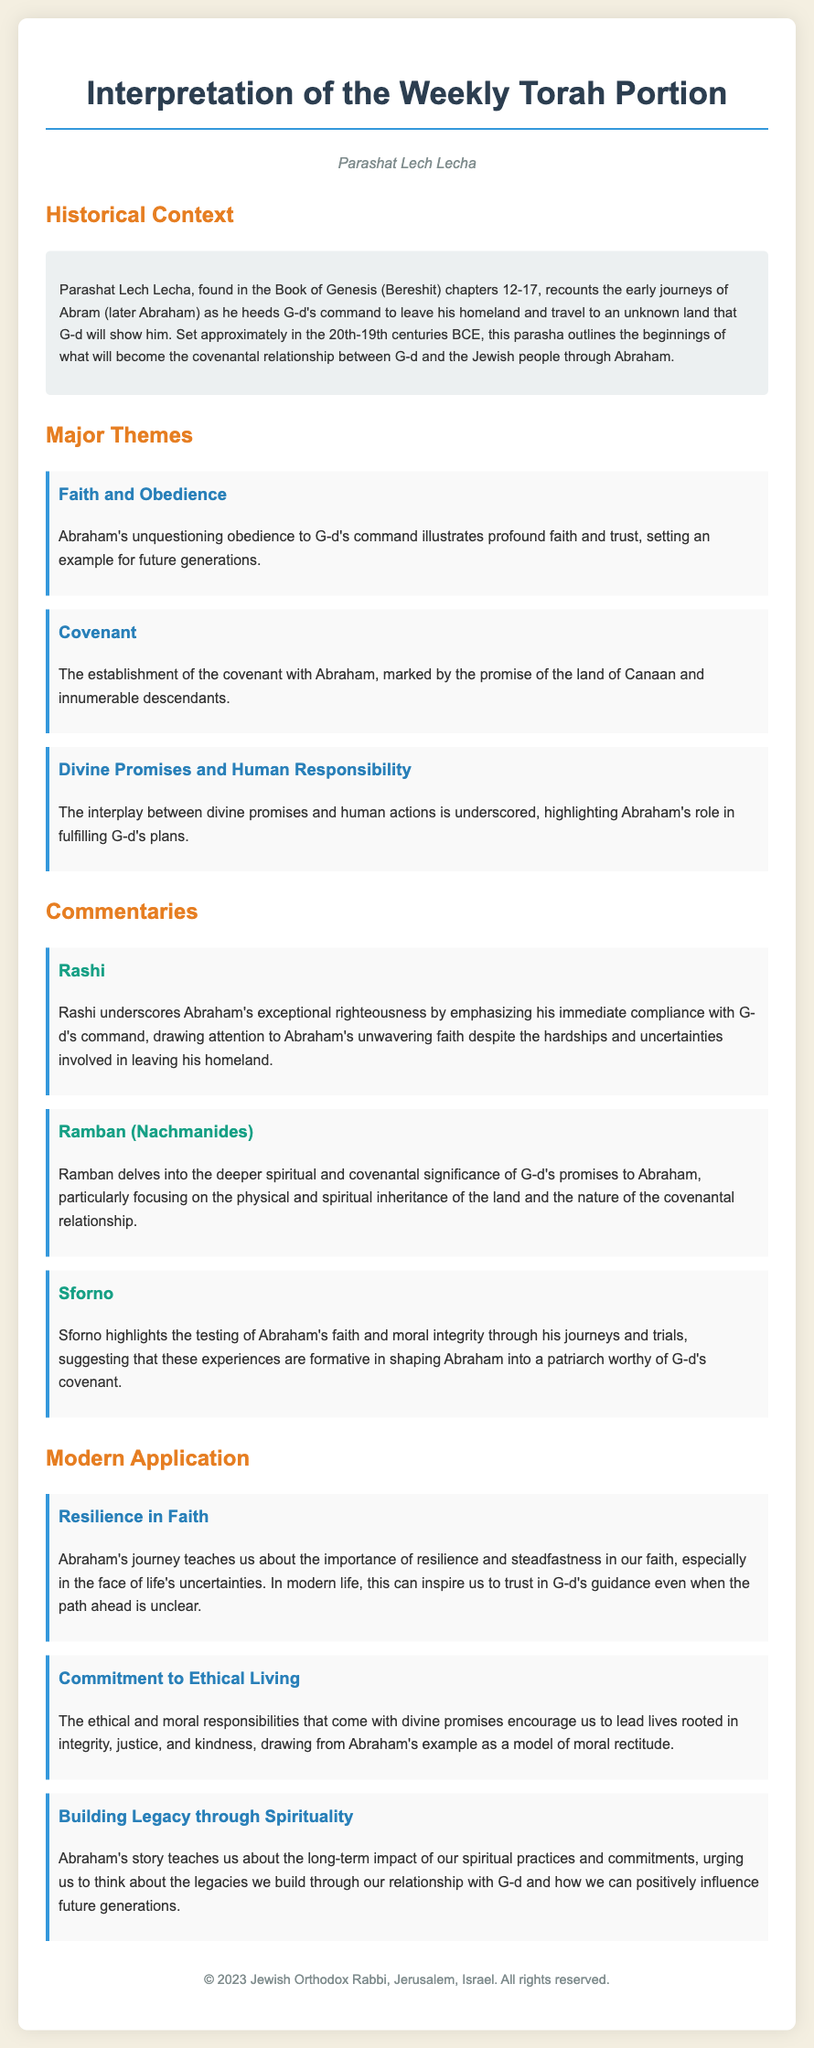what is the title of the document? The title of the document is clearly stated at the top of the rendered document.
Answer: Interpretation of the Weekly Torah Portion which parasha is being discussed? The specific parasha that is the focus of this document is mentioned prominently.
Answer: Parashat Lech Lecha how many major themes are outlined in the document? The document lists and highlights each of the major themes discussed.
Answer: Three who is emphasized as an exceptional figure in Rashi's commentary? Rashi's commentary particularly underscores the righteousness of a significant biblical figure.
Answer: Abraham what significant historical era is referenced in the context? The document specifies a time frame related to the biblical narratives.
Answer: 20th-19th centuries BCE what is one major theme discussed in the document? The document explicitly lists various major themes addressed in Parashat Lech Lecha.
Answer: Faith and Obedience which scholar focuses on the spiritual significance of G-d's promises? The commentary section attributes this focus to a prominent scholar's insights.
Answer: Ramban what modern lesson is derived from Abraham's journey? The applications section draws lessons from Abraham's experiences relevant to today.
Answer: Resilience in Faith 